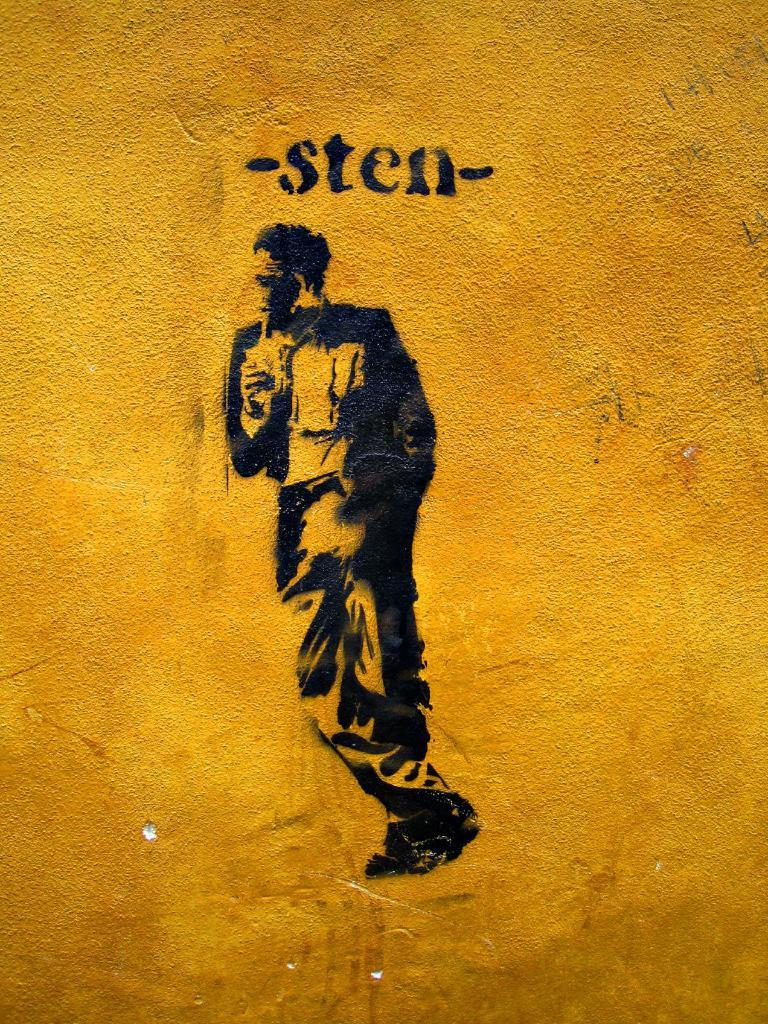<image>
Create a compact narrative representing the image presented. An image of a man stenciled with the word -sten- above him. 